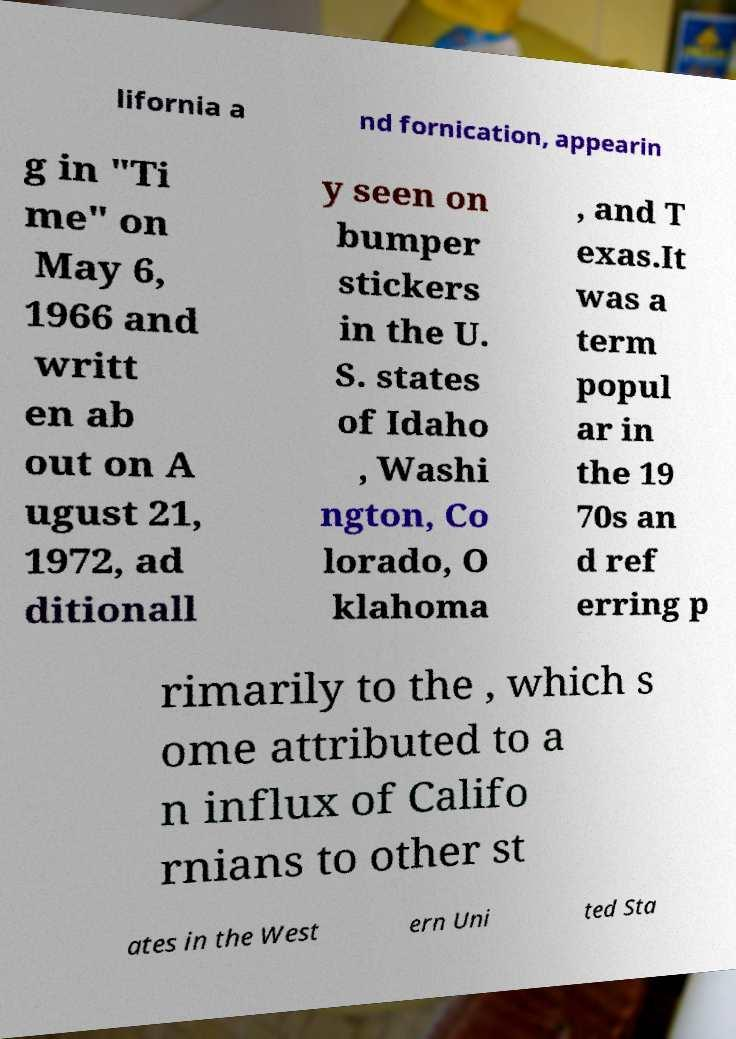What messages or text are displayed in this image? I need them in a readable, typed format. lifornia a nd fornication, appearin g in "Ti me" on May 6, 1966 and writt en ab out on A ugust 21, 1972, ad ditionall y seen on bumper stickers in the U. S. states of Idaho , Washi ngton, Co lorado, O klahoma , and T exas.It was a term popul ar in the 19 70s an d ref erring p rimarily to the , which s ome attributed to a n influx of Califo rnians to other st ates in the West ern Uni ted Sta 